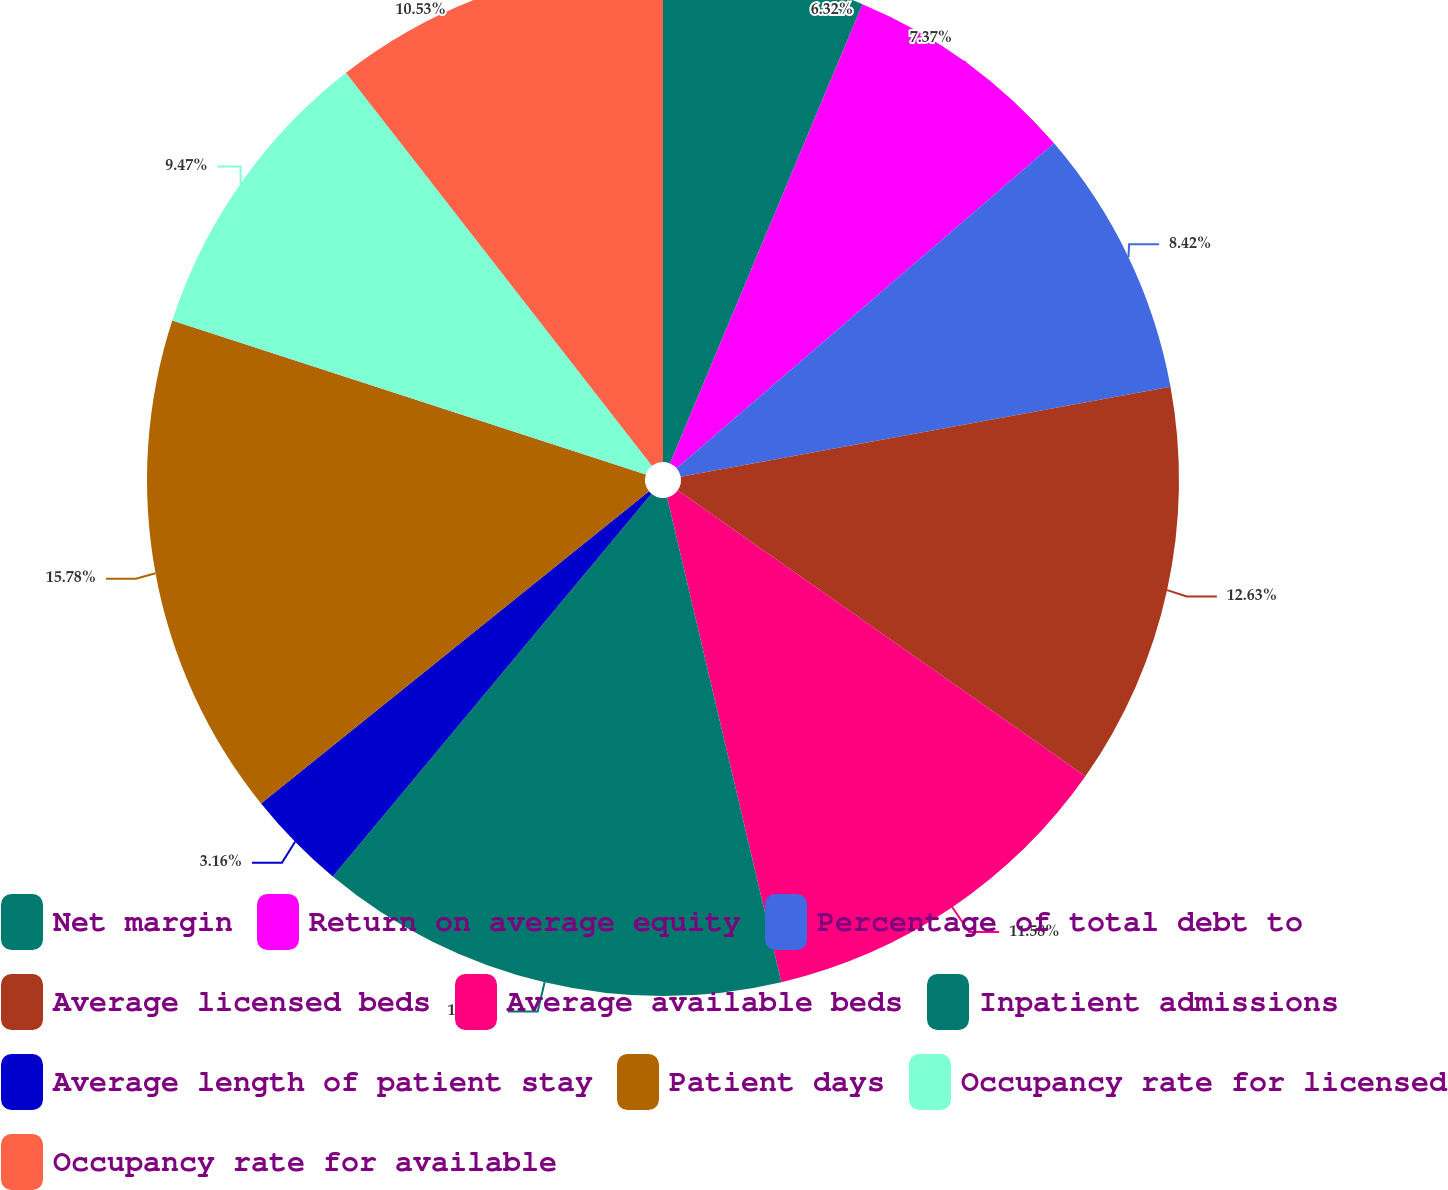Convert chart to OTSL. <chart><loc_0><loc_0><loc_500><loc_500><pie_chart><fcel>Net margin<fcel>Return on average equity<fcel>Percentage of total debt to<fcel>Average licensed beds<fcel>Average available beds<fcel>Inpatient admissions<fcel>Average length of patient stay<fcel>Patient days<fcel>Occupancy rate for licensed<fcel>Occupancy rate for available<nl><fcel>6.32%<fcel>7.37%<fcel>8.42%<fcel>12.63%<fcel>11.58%<fcel>14.74%<fcel>3.16%<fcel>15.79%<fcel>9.47%<fcel>10.53%<nl></chart> 